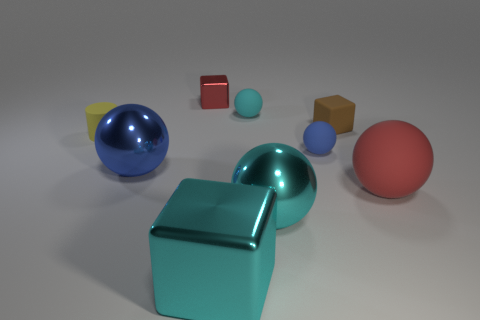Subtract all big cyan metallic spheres. How many spheres are left? 4 Subtract all red spheres. How many spheres are left? 4 Subtract all red spheres. Subtract all gray blocks. How many spheres are left? 4 Add 1 tiny red objects. How many objects exist? 10 Add 5 tiny yellow metal objects. How many tiny yellow metal objects exist? 5 Subtract 0 blue cylinders. How many objects are left? 9 Subtract all spheres. How many objects are left? 4 Subtract all tiny gray cylinders. Subtract all cyan spheres. How many objects are left? 7 Add 7 small yellow objects. How many small yellow objects are left? 8 